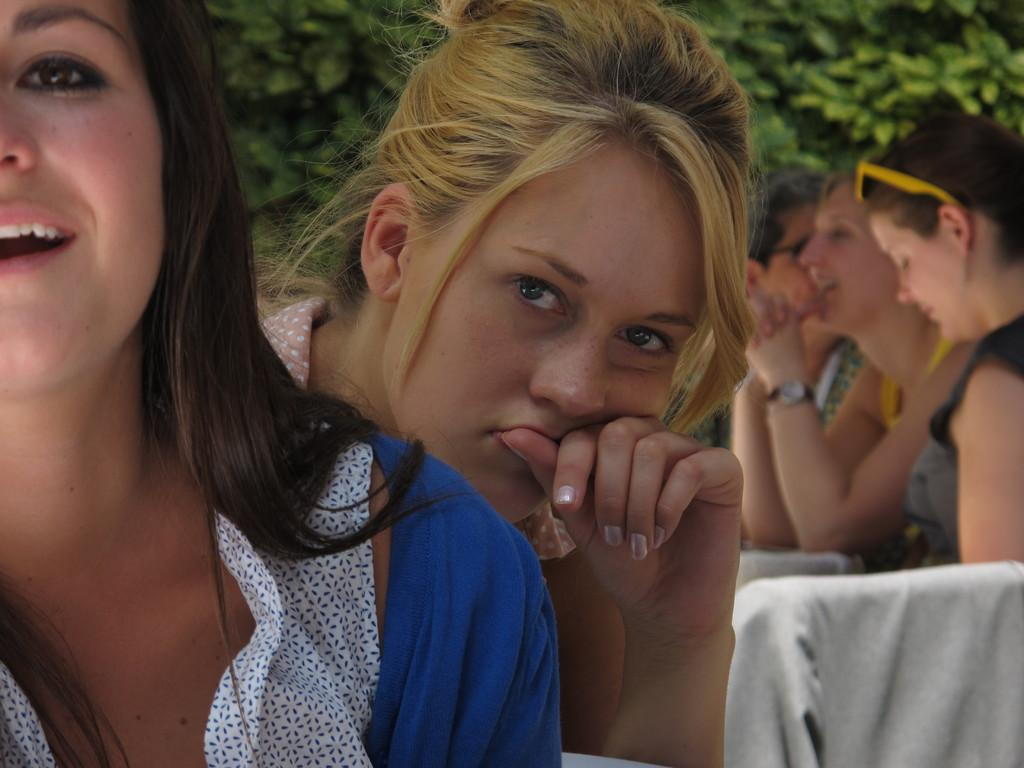How many people are present in the image? There are many people in the image. Can you describe any accessories worn by the ladies in the image? One lady is wearing a watch, and another lady has goggles on her head. What can be seen in the background of the image? There are leaves visible in the background of the image. How many legs does the giant have in the image? There are no giants present in the image, so it is not possible to determine the number of legs they might have. 